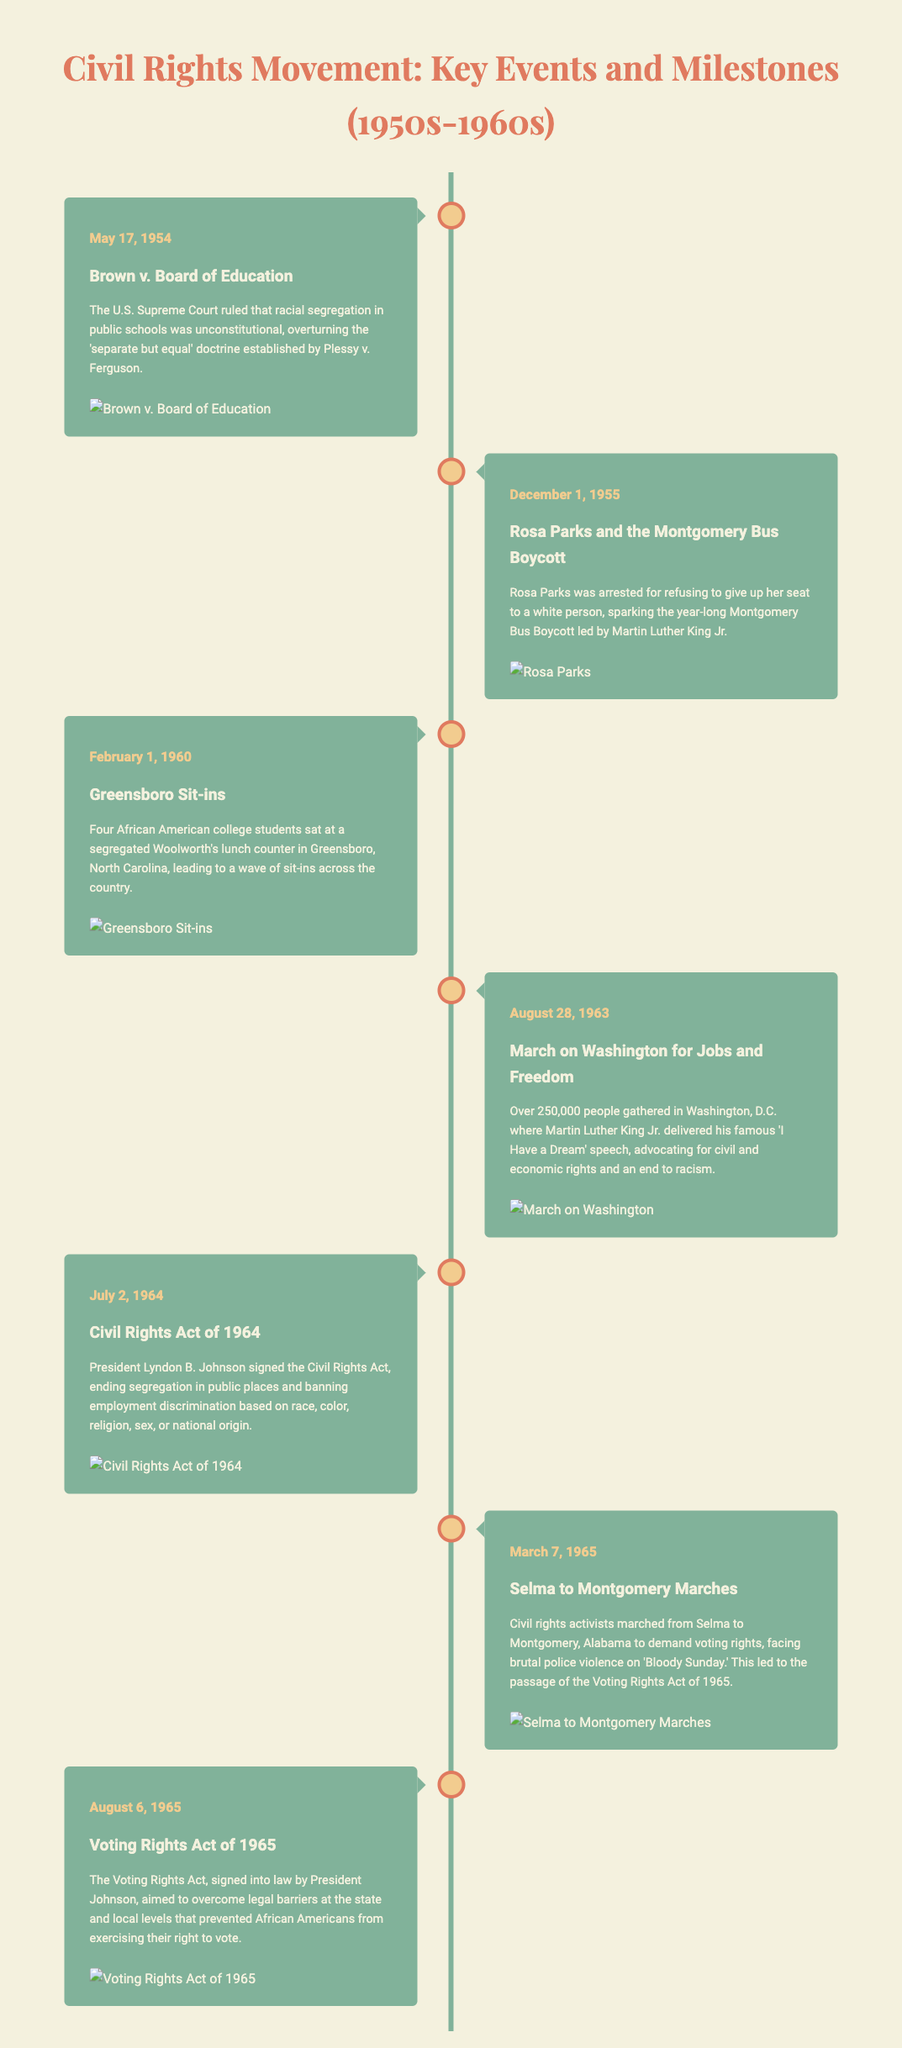What date was the Brown v. Board of Education decision? The Brown v. Board of Education decision is marked with the date May 17, 1954 in the document.
Answer: May 17, 1954 Who delivered the "I Have a Dream" speech? The timeline states that Martin Luther King Jr. delivered his famous "I Have a Dream" speech during the March on Washington event.
Answer: Martin Luther King Jr What event sparked the Montgomery Bus Boycott? The document mentions Rosa Parks' arrest for refusing to give up her seat, which sparked the Montgomery Bus Boycott.
Answer: Rosa Parks' arrest In what year was the Civil Rights Act signed? The timeline states that the Civil Rights Act was signed on July 2, 1964.
Answer: July 2, 1964 What was the primary aim of the Voting Rights Act of 1965? According to the document, the primary aim was to overcome barriers preventing African Americans from exercising their right to vote.
Answer: Voting rights Which event was referred to as 'Bloody Sunday'? The Selma to Montgomery Marches faced brutal police violence on a day referred to as 'Bloody Sunday' according to the timeline.
Answer: Selma to Montgomery Marches How many people gathered for the March on Washington? The document states that over 250,000 people gathered for the March on Washington.
Answer: 250,000 What was the significance of the Greensboro Sit-ins? The Greensboro Sit-ins led to a wave of sit-ins across the country, marking a significant form of protest against segregation.
Answer: Wave of sit-ins What color is associated with the timeline's event marker? The event marker in the timeline is a shade of green indicated by the color code #81b29a.
Answer: Green 